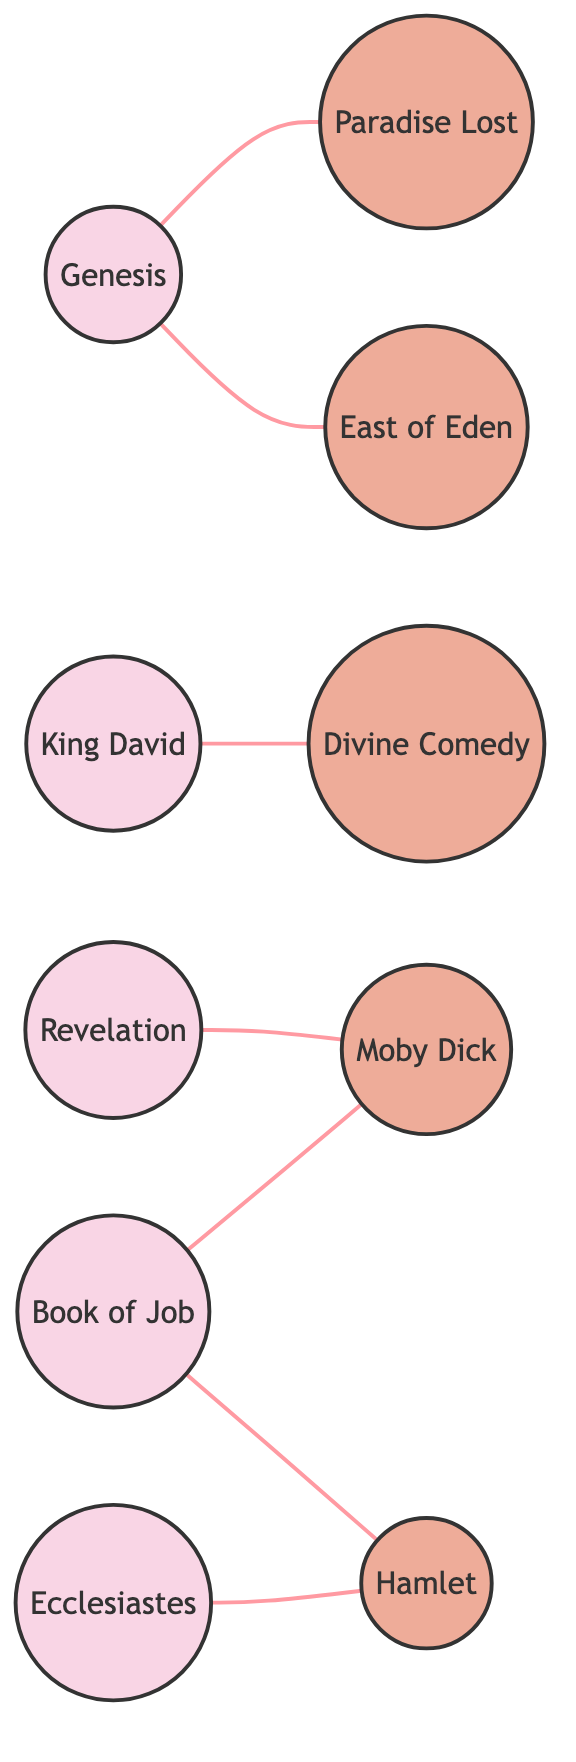What is the total number of nodes in the diagram? The diagram contains nodes representing both biblical references and literary works. By counting each unique node listed in the data, we find 10 nodes in total.
Answer: 10 Which literary work is directly connected to Genesis? In the diagram, Genesis is linked to Paradise Lost and East of Eden. These are the only literary works that connect directly to Genesis.
Answer: Paradise Lost, East of Eden How many edges are there connecting the nodes? Each edge represents a relationship between two nodes. By counting the edges listed in the data, we see that there are 7 edges in total connecting the nodes.
Answer: 7 Which biblical reference connects to Hamlet? The edges indicate that both Job and Ecclesiastes are directly linked to Hamlet. Therefore, the biblical references that connect to Hamlet are Job and Ecclesiastes.
Answer: Job, Ecclesiastes What is the relationship between King David and Divine Comedy? The diagram shows a direct edge connecting King David to Divine Comedy, indicating they share a relationship in this context.
Answer: Direct connection Which biblical references connect to Moby Dick? Moby Dick is shown to have edges connecting to both Revelation and Job, indicating both biblical references are related to this literary work.
Answer: Revelation, Job How many literary works are connected to Genesis? By examining the edges, we find that Genesis connects to two literary works: Paradise Lost and East of Eden. Thus, the number of literary works connected to Genesis is 2.
Answer: 2 Which two nodes do not share any direct connection? To determine nodes without direct connections, we look for isolated nodes with no edges between them. By reviewing the edges, we can identify which nodes are not directly linked. In this case, "King David" and "East of Eden" do not share a direct connection.
Answer: King David, East of Eden Which biblical reference has the most connections? To find the biblical reference with the most connections, we can count the edges for each biblical node. "Job" has connections to both Moby Dick and Hamlet, making it a node with multiple connections.
Answer: Job 